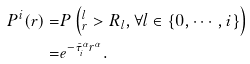Convert formula to latex. <formula><loc_0><loc_0><loc_500><loc_500>P ^ { i } ( r ) = & P \left ( ^ { l } _ { r } > R _ { l } , \forall l \in \{ 0 , \cdots , i \} \right ) \\ = & e ^ { - \bar { \tau } _ { i } ^ { \alpha } r ^ { \alpha } } .</formula> 